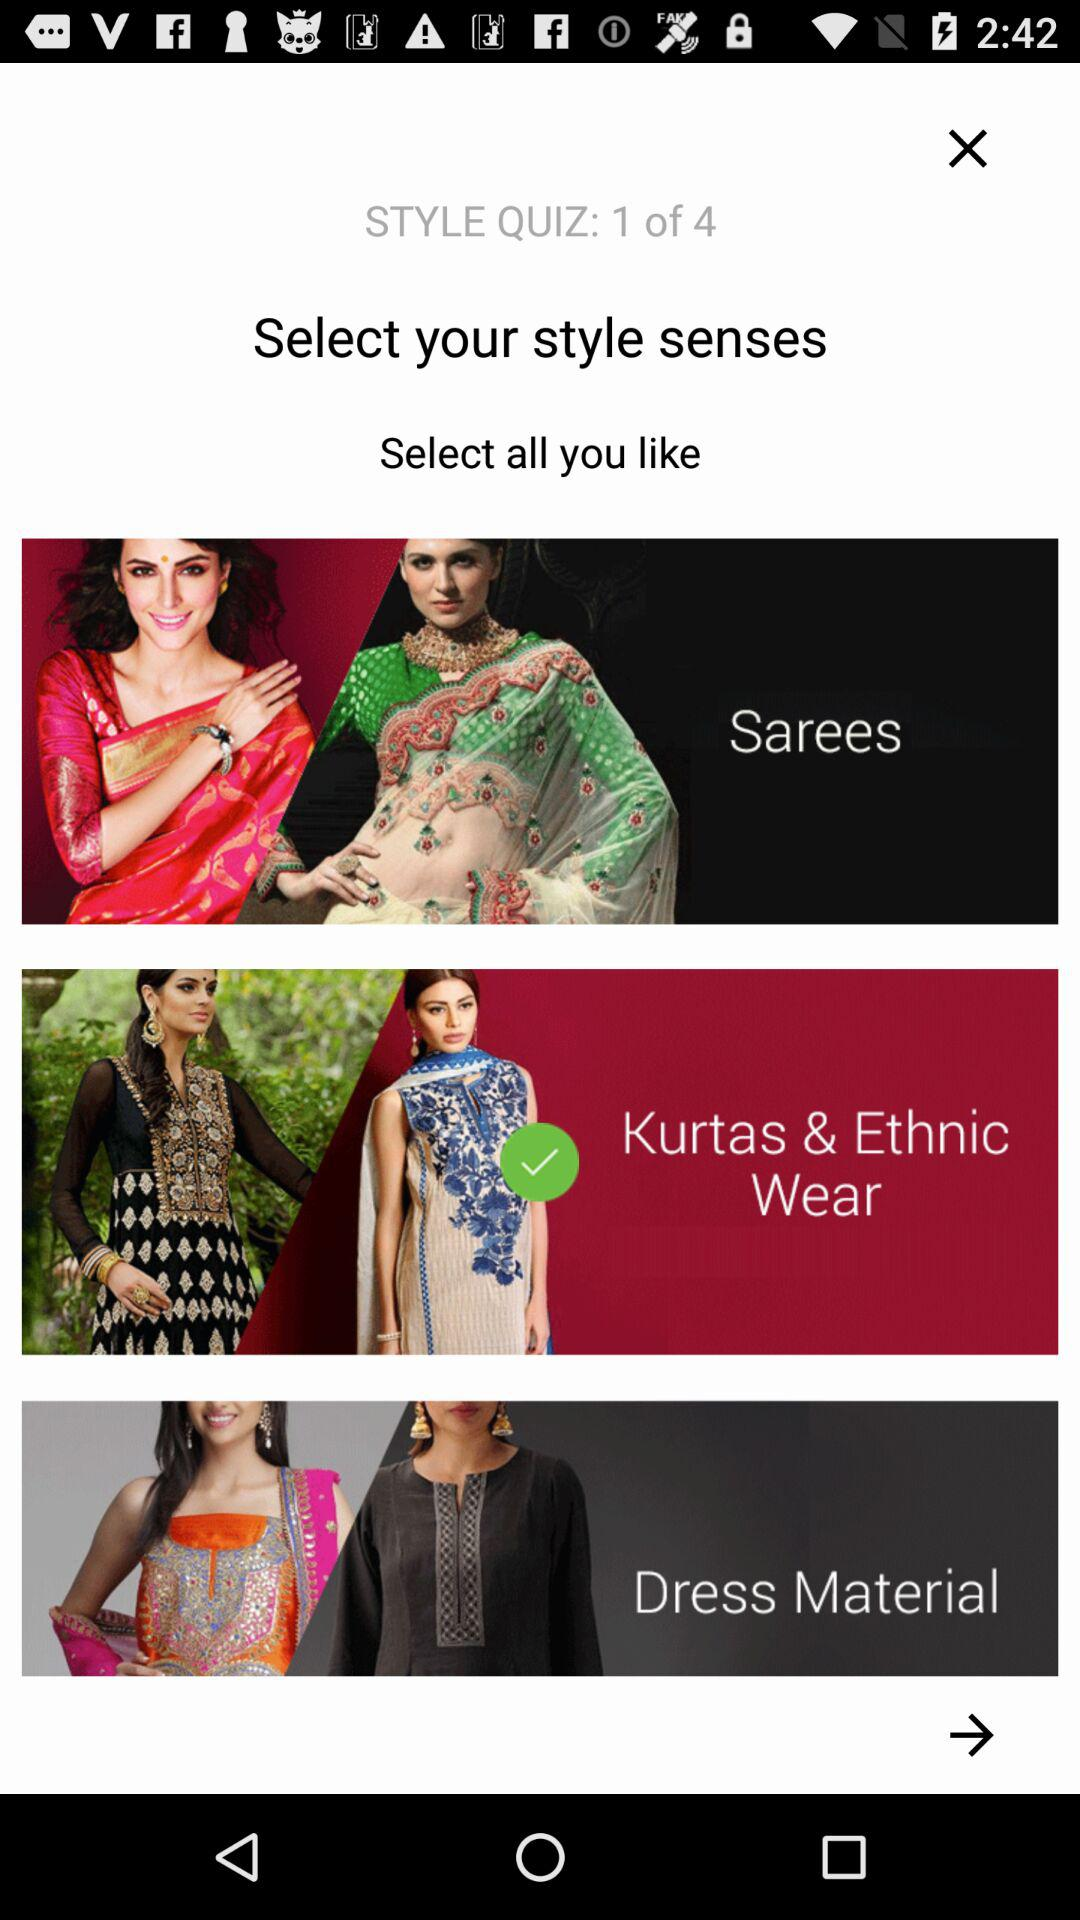How many questions are there in the quiz? There are 4 questions in the quiz. 